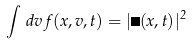<formula> <loc_0><loc_0><loc_500><loc_500>\int \, d v \, f ( x , v , t ) = | \psi ( x , t ) | ^ { 2 }</formula> 